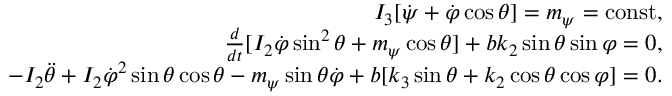Convert formula to latex. <formula><loc_0><loc_0><loc_500><loc_500>\begin{array} { r } { I _ { 3 } [ \dot { \psi } + \dot { \varphi } \cos \theta ] = m _ { \psi } = c o n s t , } \\ { \frac { d } { d t } [ I _ { 2 } \dot { \varphi } \sin ^ { 2 } \theta + m _ { \psi } \cos \theta ] + b k _ { 2 } \sin \theta \sin \varphi = 0 , } \\ { - I _ { 2 } \ddot { \theta } + I _ { 2 } \dot { \varphi } ^ { 2 } \sin \theta \cos \theta - m _ { \psi } \sin \theta \dot { \varphi } + b [ k _ { 3 } \sin \theta + k _ { 2 } \cos \theta \cos \varphi ] = 0 . } \end{array}</formula> 